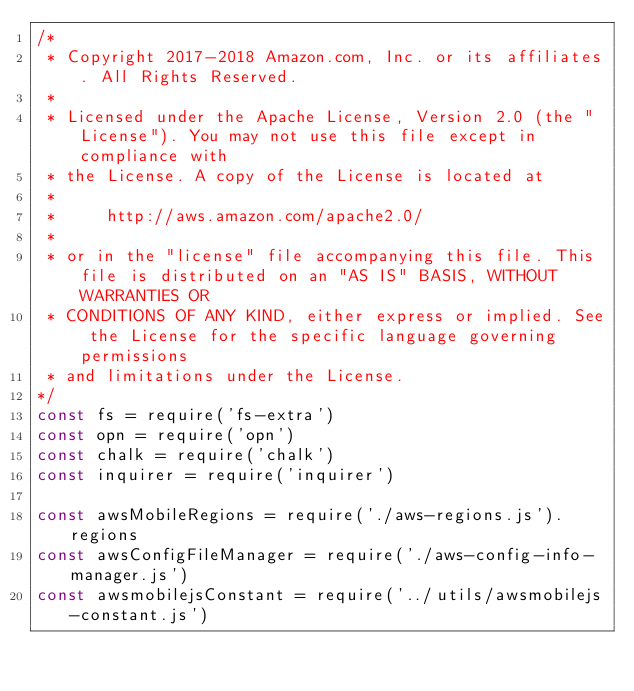<code> <loc_0><loc_0><loc_500><loc_500><_JavaScript_>/* 
 * Copyright 2017-2018 Amazon.com, Inc. or its affiliates. All Rights Reserved.
 *
 * Licensed under the Apache License, Version 2.0 (the "License"). You may not use this file except in compliance with
 * the License. A copy of the License is located at
 *
 *     http://aws.amazon.com/apache2.0/
 *
 * or in the "license" file accompanying this file. This file is distributed on an "AS IS" BASIS, WITHOUT WARRANTIES OR
 * CONDITIONS OF ANY KIND, either express or implied. See the License for the specific language governing permissions
 * and limitations under the License.
*/
const fs = require('fs-extra')
const opn = require('opn')
const chalk = require('chalk')
const inquirer = require('inquirer')

const awsMobileRegions = require('./aws-regions.js').regions
const awsConfigFileManager = require('./aws-config-info-manager.js')
const awsmobilejsConstant = require('../utils/awsmobilejs-constant.js')</code> 